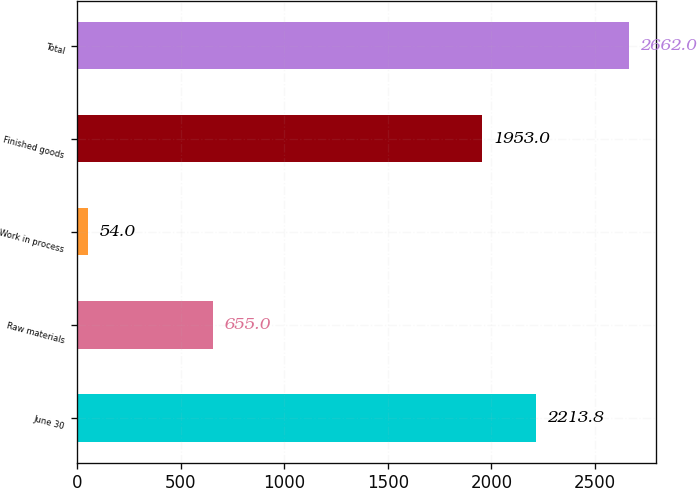Convert chart to OTSL. <chart><loc_0><loc_0><loc_500><loc_500><bar_chart><fcel>June 30<fcel>Raw materials<fcel>Work in process<fcel>Finished goods<fcel>Total<nl><fcel>2213.8<fcel>655<fcel>54<fcel>1953<fcel>2662<nl></chart> 